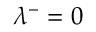Convert formula to latex. <formula><loc_0><loc_0><loc_500><loc_500>\lambda ^ { - } = 0</formula> 